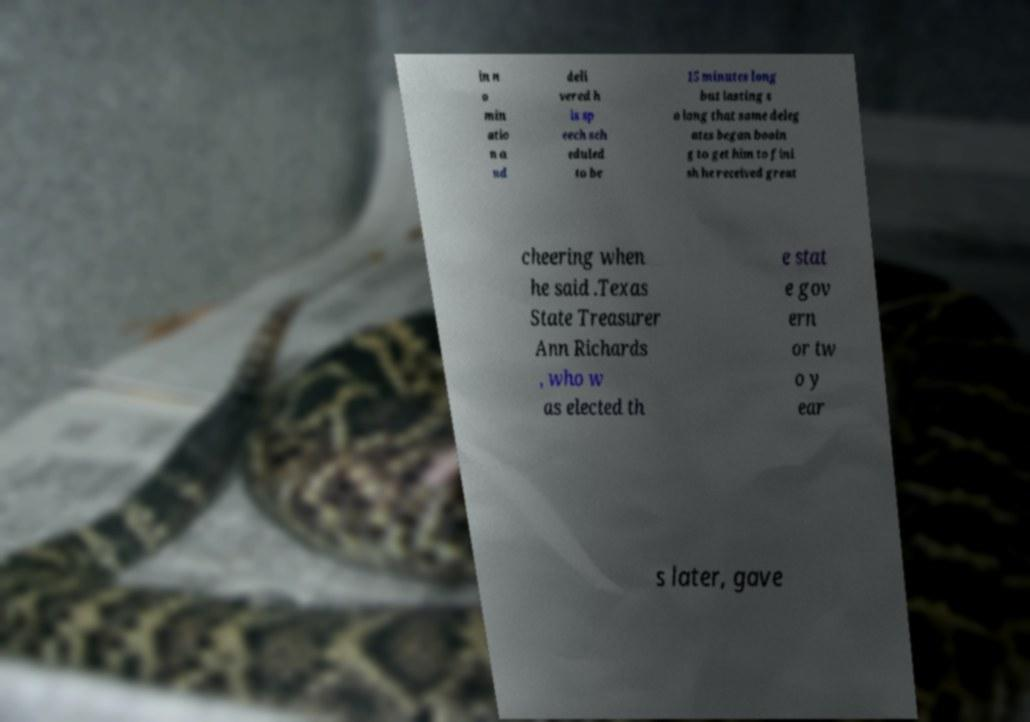There's text embedded in this image that I need extracted. Can you transcribe it verbatim? in n o min atio n a nd deli vered h is sp eech sch eduled to be 15 minutes long but lasting s o long that some deleg ates began booin g to get him to fini sh he received great cheering when he said .Texas State Treasurer Ann Richards , who w as elected th e stat e gov ern or tw o y ear s later, gave 